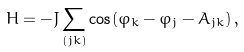<formula> <loc_0><loc_0><loc_500><loc_500>H = - J \sum _ { ( j k ) } \cos ( \varphi _ { k } - \varphi _ { j } - A _ { j k } ) \, ,</formula> 